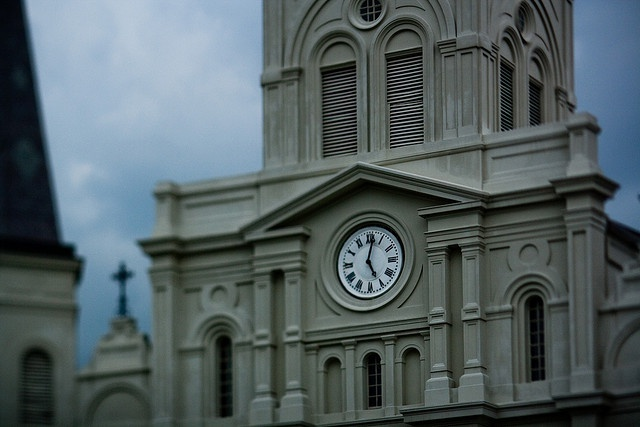Describe the objects in this image and their specific colors. I can see a clock in black, darkgray, and gray tones in this image. 